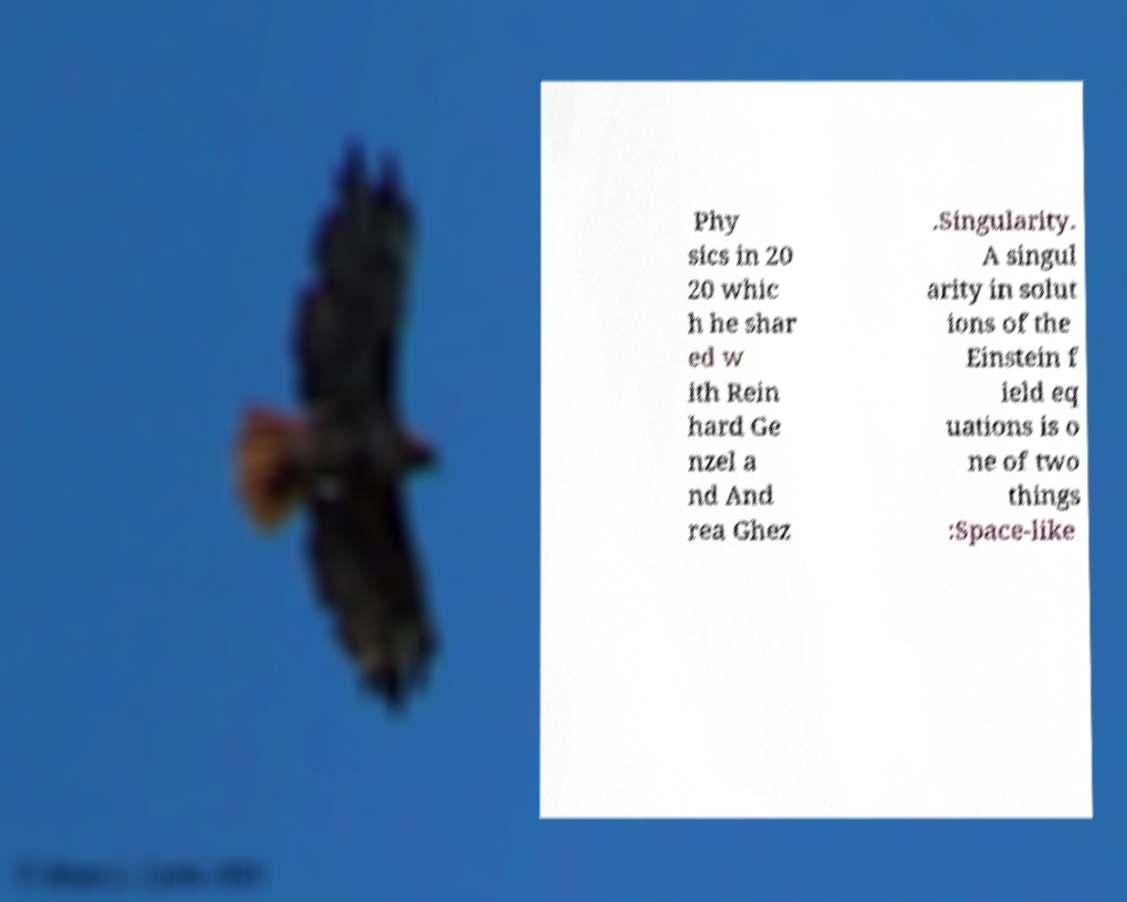There's text embedded in this image that I need extracted. Can you transcribe it verbatim? Phy sics in 20 20 whic h he shar ed w ith Rein hard Ge nzel a nd And rea Ghez .Singularity. A singul arity in solut ions of the Einstein f ield eq uations is o ne of two things :Space-like 